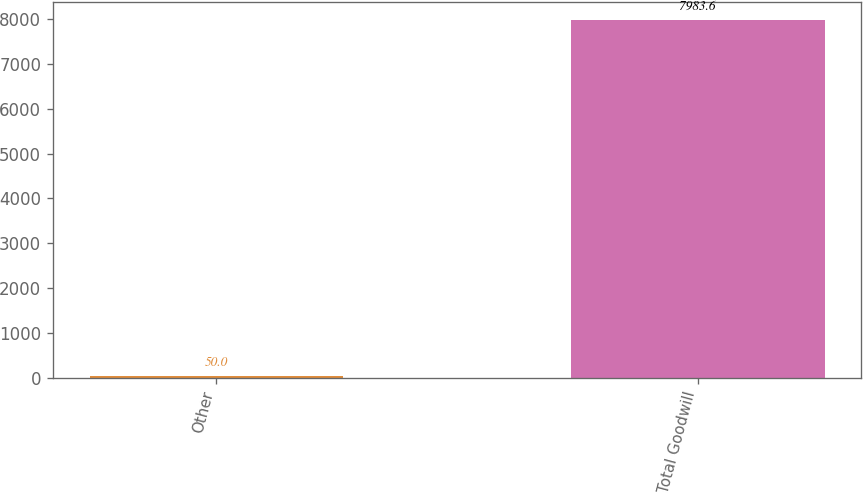<chart> <loc_0><loc_0><loc_500><loc_500><bar_chart><fcel>Other<fcel>Total Goodwill<nl><fcel>50<fcel>7983.6<nl></chart> 